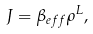Convert formula to latex. <formula><loc_0><loc_0><loc_500><loc_500>J = \beta _ { e f f } \rho ^ { L } ,</formula> 